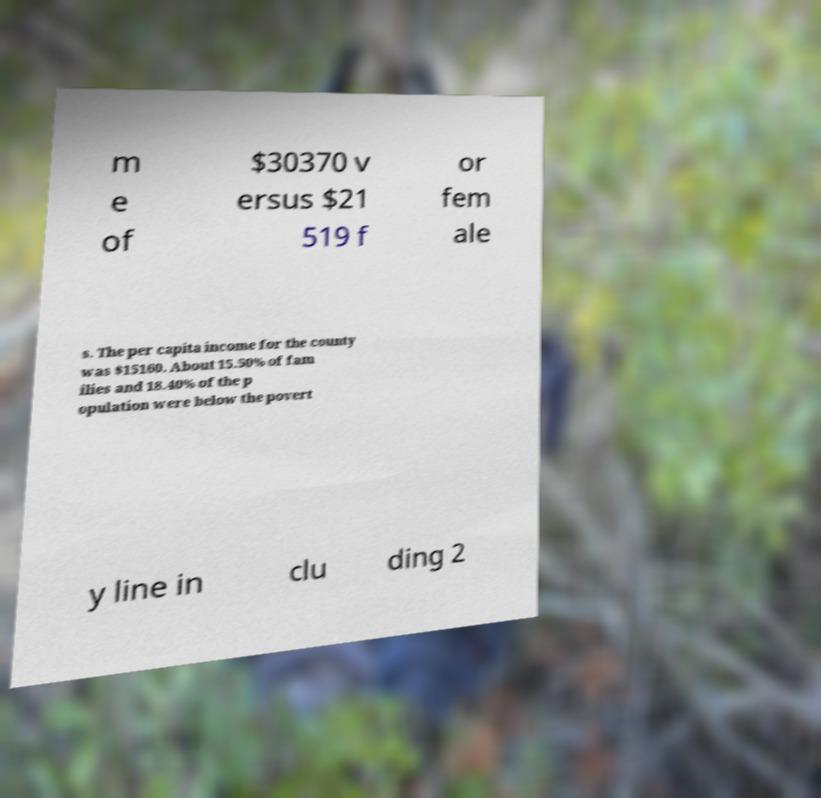There's text embedded in this image that I need extracted. Can you transcribe it verbatim? m e of $30370 v ersus $21 519 f or fem ale s. The per capita income for the county was $15160. About 15.50% of fam ilies and 18.40% of the p opulation were below the povert y line in clu ding 2 